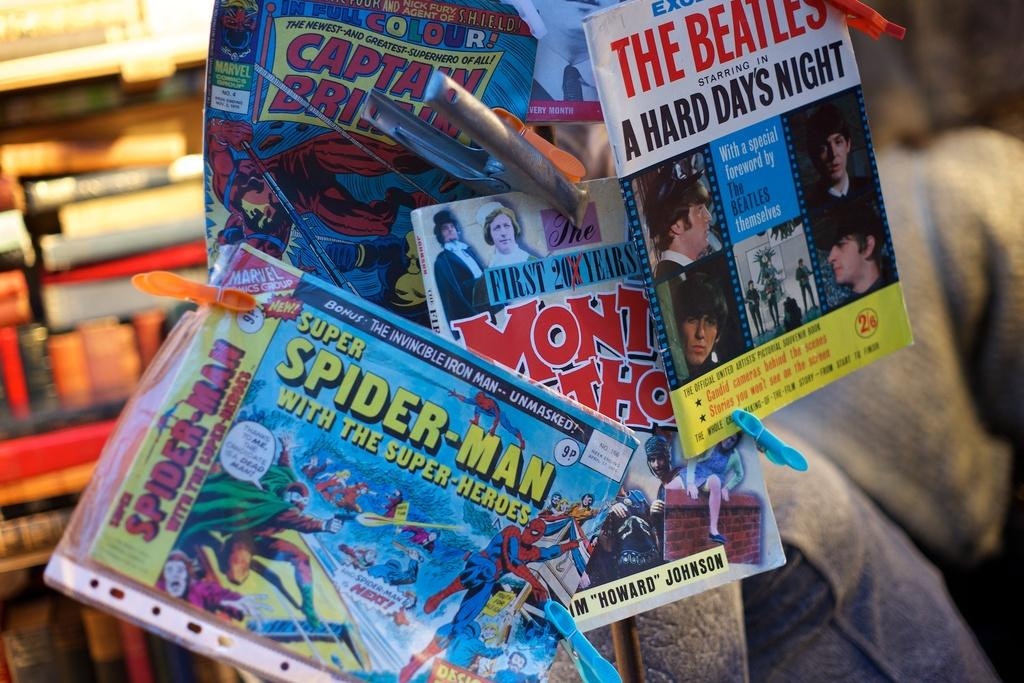<image>
Create a compact narrative representing the image presented. Several comic books, the frontmost of which features Spider-man. 